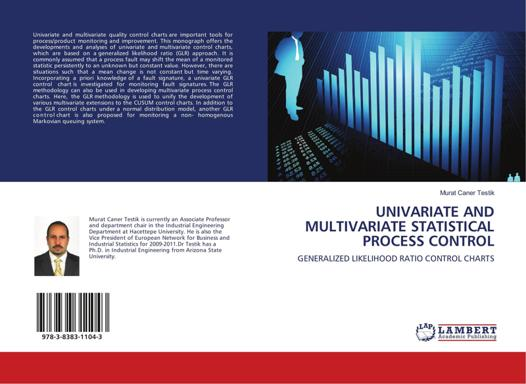Based on the image, what is the topic of the book? The book is titled 'Univariate and Multivariate Statistical Process Control', focusing extensively on Generalized Likelihood Ratio Control Charts. It appears to be a scholarly work, likely combining theory with practical applications in statistical process monitoring and quality control, pivotal for ensuring systematic dependability in various industrial and business processes. 